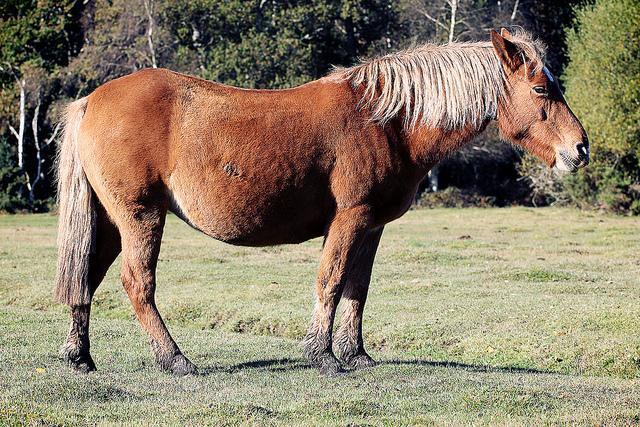How many horses are in this image?
Give a very brief answer. 1. How many people are laying down?
Give a very brief answer. 0. 